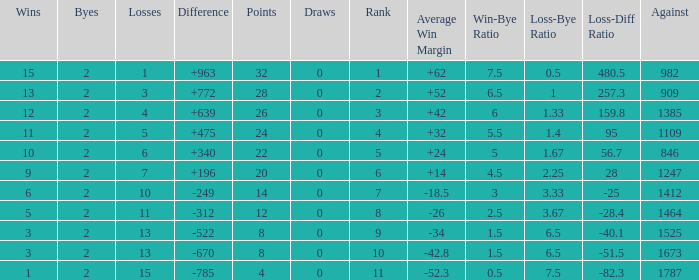What is the number listed under against when there were less than 13 losses and less than 2 byes? 0.0. 